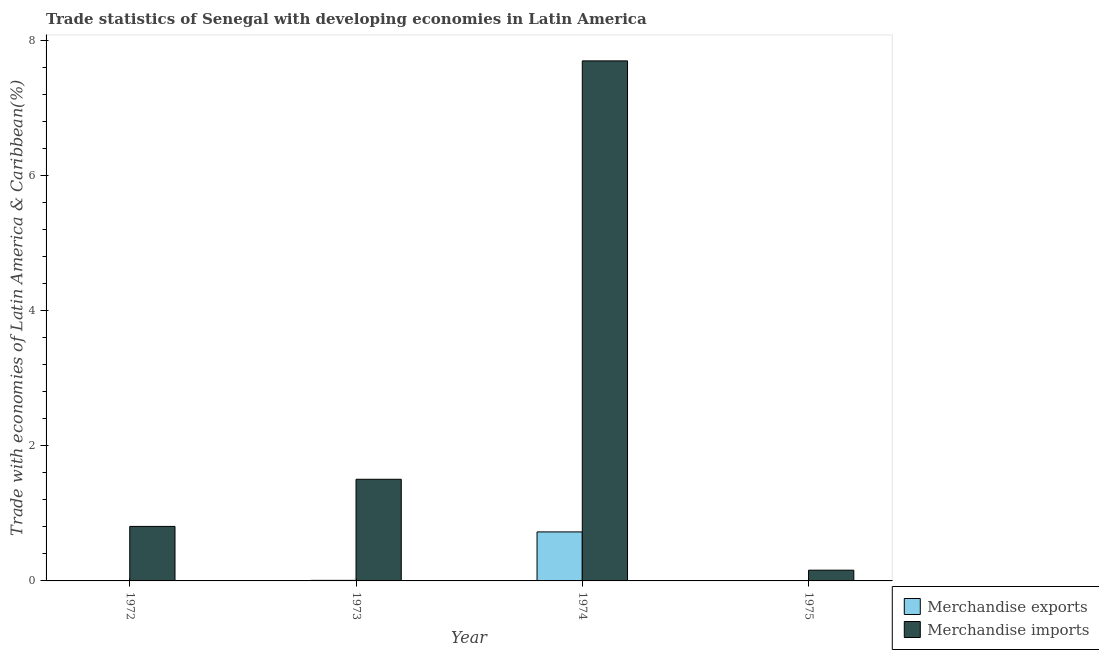How many different coloured bars are there?
Give a very brief answer. 2. How many groups of bars are there?
Give a very brief answer. 4. Are the number of bars on each tick of the X-axis equal?
Your answer should be compact. Yes. How many bars are there on the 1st tick from the left?
Keep it short and to the point. 2. How many bars are there on the 3rd tick from the right?
Your response must be concise. 2. What is the label of the 3rd group of bars from the left?
Your answer should be compact. 1974. In how many cases, is the number of bars for a given year not equal to the number of legend labels?
Your answer should be very brief. 0. What is the merchandise imports in 1972?
Ensure brevity in your answer.  0.81. Across all years, what is the maximum merchandise exports?
Keep it short and to the point. 0.73. Across all years, what is the minimum merchandise imports?
Offer a very short reply. 0.16. In which year was the merchandise imports maximum?
Your answer should be very brief. 1974. In which year was the merchandise imports minimum?
Offer a terse response. 1975. What is the total merchandise exports in the graph?
Offer a terse response. 0.74. What is the difference between the merchandise exports in 1974 and that in 1975?
Make the answer very short. 0.72. What is the difference between the merchandise imports in 1975 and the merchandise exports in 1972?
Ensure brevity in your answer.  -0.65. What is the average merchandise exports per year?
Your answer should be compact. 0.19. In the year 1974, what is the difference between the merchandise exports and merchandise imports?
Give a very brief answer. 0. What is the ratio of the merchandise imports in 1972 to that in 1975?
Ensure brevity in your answer.  5.08. Is the difference between the merchandise imports in 1973 and 1974 greater than the difference between the merchandise exports in 1973 and 1974?
Your answer should be very brief. No. What is the difference between the highest and the second highest merchandise imports?
Offer a terse response. 6.19. What is the difference between the highest and the lowest merchandise imports?
Your answer should be very brief. 7.54. In how many years, is the merchandise exports greater than the average merchandise exports taken over all years?
Keep it short and to the point. 1. Is the sum of the merchandise exports in 1974 and 1975 greater than the maximum merchandise imports across all years?
Ensure brevity in your answer.  Yes. What does the 2nd bar from the left in 1973 represents?
Make the answer very short. Merchandise imports. What does the 1st bar from the right in 1975 represents?
Keep it short and to the point. Merchandise imports. Are all the bars in the graph horizontal?
Provide a short and direct response. No. How many years are there in the graph?
Provide a short and direct response. 4. What is the difference between two consecutive major ticks on the Y-axis?
Offer a very short reply. 2. How are the legend labels stacked?
Your answer should be very brief. Vertical. What is the title of the graph?
Your response must be concise. Trade statistics of Senegal with developing economies in Latin America. Does "Females" appear as one of the legend labels in the graph?
Your response must be concise. No. What is the label or title of the Y-axis?
Give a very brief answer. Trade with economies of Latin America & Caribbean(%). What is the Trade with economies of Latin America & Caribbean(%) in Merchandise exports in 1972?
Your response must be concise. 0.01. What is the Trade with economies of Latin America & Caribbean(%) of Merchandise imports in 1972?
Your answer should be very brief. 0.81. What is the Trade with economies of Latin America & Caribbean(%) of Merchandise exports in 1973?
Offer a very short reply. 0.01. What is the Trade with economies of Latin America & Caribbean(%) of Merchandise imports in 1973?
Give a very brief answer. 1.5. What is the Trade with economies of Latin America & Caribbean(%) in Merchandise exports in 1974?
Your answer should be very brief. 0.73. What is the Trade with economies of Latin America & Caribbean(%) of Merchandise imports in 1974?
Provide a succinct answer. 7.7. What is the Trade with economies of Latin America & Caribbean(%) in Merchandise exports in 1975?
Your answer should be compact. 0. What is the Trade with economies of Latin America & Caribbean(%) of Merchandise imports in 1975?
Make the answer very short. 0.16. Across all years, what is the maximum Trade with economies of Latin America & Caribbean(%) in Merchandise exports?
Keep it short and to the point. 0.73. Across all years, what is the maximum Trade with economies of Latin America & Caribbean(%) in Merchandise imports?
Offer a very short reply. 7.7. Across all years, what is the minimum Trade with economies of Latin America & Caribbean(%) of Merchandise exports?
Your answer should be compact. 0. Across all years, what is the minimum Trade with economies of Latin America & Caribbean(%) of Merchandise imports?
Provide a short and direct response. 0.16. What is the total Trade with economies of Latin America & Caribbean(%) in Merchandise exports in the graph?
Your response must be concise. 0.74. What is the total Trade with economies of Latin America & Caribbean(%) in Merchandise imports in the graph?
Offer a terse response. 10.17. What is the difference between the Trade with economies of Latin America & Caribbean(%) in Merchandise exports in 1972 and that in 1973?
Ensure brevity in your answer.  -0. What is the difference between the Trade with economies of Latin America & Caribbean(%) of Merchandise imports in 1972 and that in 1973?
Offer a terse response. -0.7. What is the difference between the Trade with economies of Latin America & Caribbean(%) in Merchandise exports in 1972 and that in 1974?
Ensure brevity in your answer.  -0.72. What is the difference between the Trade with economies of Latin America & Caribbean(%) in Merchandise imports in 1972 and that in 1974?
Keep it short and to the point. -6.89. What is the difference between the Trade with economies of Latin America & Caribbean(%) in Merchandise exports in 1972 and that in 1975?
Offer a terse response. 0. What is the difference between the Trade with economies of Latin America & Caribbean(%) in Merchandise imports in 1972 and that in 1975?
Your answer should be very brief. 0.65. What is the difference between the Trade with economies of Latin America & Caribbean(%) in Merchandise exports in 1973 and that in 1974?
Provide a short and direct response. -0.72. What is the difference between the Trade with economies of Latin America & Caribbean(%) in Merchandise imports in 1973 and that in 1974?
Give a very brief answer. -6.19. What is the difference between the Trade with economies of Latin America & Caribbean(%) in Merchandise exports in 1973 and that in 1975?
Offer a very short reply. 0.01. What is the difference between the Trade with economies of Latin America & Caribbean(%) of Merchandise imports in 1973 and that in 1975?
Your response must be concise. 1.35. What is the difference between the Trade with economies of Latin America & Caribbean(%) in Merchandise exports in 1974 and that in 1975?
Give a very brief answer. 0.72. What is the difference between the Trade with economies of Latin America & Caribbean(%) of Merchandise imports in 1974 and that in 1975?
Provide a short and direct response. 7.54. What is the difference between the Trade with economies of Latin America & Caribbean(%) of Merchandise exports in 1972 and the Trade with economies of Latin America & Caribbean(%) of Merchandise imports in 1973?
Keep it short and to the point. -1.5. What is the difference between the Trade with economies of Latin America & Caribbean(%) in Merchandise exports in 1972 and the Trade with economies of Latin America & Caribbean(%) in Merchandise imports in 1974?
Provide a short and direct response. -7.69. What is the difference between the Trade with economies of Latin America & Caribbean(%) of Merchandise exports in 1972 and the Trade with economies of Latin America & Caribbean(%) of Merchandise imports in 1975?
Give a very brief answer. -0.15. What is the difference between the Trade with economies of Latin America & Caribbean(%) of Merchandise exports in 1973 and the Trade with economies of Latin America & Caribbean(%) of Merchandise imports in 1974?
Ensure brevity in your answer.  -7.69. What is the difference between the Trade with economies of Latin America & Caribbean(%) of Merchandise exports in 1973 and the Trade with economies of Latin America & Caribbean(%) of Merchandise imports in 1975?
Keep it short and to the point. -0.15. What is the difference between the Trade with economies of Latin America & Caribbean(%) of Merchandise exports in 1974 and the Trade with economies of Latin America & Caribbean(%) of Merchandise imports in 1975?
Your answer should be very brief. 0.57. What is the average Trade with economies of Latin America & Caribbean(%) of Merchandise exports per year?
Keep it short and to the point. 0.19. What is the average Trade with economies of Latin America & Caribbean(%) of Merchandise imports per year?
Keep it short and to the point. 2.54. In the year 1972, what is the difference between the Trade with economies of Latin America & Caribbean(%) of Merchandise exports and Trade with economies of Latin America & Caribbean(%) of Merchandise imports?
Keep it short and to the point. -0.8. In the year 1973, what is the difference between the Trade with economies of Latin America & Caribbean(%) in Merchandise exports and Trade with economies of Latin America & Caribbean(%) in Merchandise imports?
Provide a succinct answer. -1.5. In the year 1974, what is the difference between the Trade with economies of Latin America & Caribbean(%) in Merchandise exports and Trade with economies of Latin America & Caribbean(%) in Merchandise imports?
Offer a very short reply. -6.97. In the year 1975, what is the difference between the Trade with economies of Latin America & Caribbean(%) of Merchandise exports and Trade with economies of Latin America & Caribbean(%) of Merchandise imports?
Give a very brief answer. -0.16. What is the ratio of the Trade with economies of Latin America & Caribbean(%) of Merchandise exports in 1972 to that in 1973?
Provide a short and direct response. 0.73. What is the ratio of the Trade with economies of Latin America & Caribbean(%) in Merchandise imports in 1972 to that in 1973?
Provide a succinct answer. 0.54. What is the ratio of the Trade with economies of Latin America & Caribbean(%) in Merchandise exports in 1972 to that in 1974?
Your answer should be very brief. 0.01. What is the ratio of the Trade with economies of Latin America & Caribbean(%) in Merchandise imports in 1972 to that in 1974?
Your response must be concise. 0.1. What is the ratio of the Trade with economies of Latin America & Caribbean(%) of Merchandise exports in 1972 to that in 1975?
Ensure brevity in your answer.  1.98. What is the ratio of the Trade with economies of Latin America & Caribbean(%) of Merchandise imports in 1972 to that in 1975?
Ensure brevity in your answer.  5.08. What is the ratio of the Trade with economies of Latin America & Caribbean(%) of Merchandise exports in 1973 to that in 1974?
Ensure brevity in your answer.  0.01. What is the ratio of the Trade with economies of Latin America & Caribbean(%) of Merchandise imports in 1973 to that in 1974?
Provide a succinct answer. 0.2. What is the ratio of the Trade with economies of Latin America & Caribbean(%) of Merchandise exports in 1973 to that in 1975?
Your answer should be compact. 2.71. What is the ratio of the Trade with economies of Latin America & Caribbean(%) of Merchandise imports in 1973 to that in 1975?
Provide a short and direct response. 9.47. What is the ratio of the Trade with economies of Latin America & Caribbean(%) in Merchandise exports in 1974 to that in 1975?
Offer a very short reply. 239.55. What is the ratio of the Trade with economies of Latin America & Caribbean(%) of Merchandise imports in 1974 to that in 1975?
Your response must be concise. 48.43. What is the difference between the highest and the second highest Trade with economies of Latin America & Caribbean(%) in Merchandise exports?
Your answer should be very brief. 0.72. What is the difference between the highest and the second highest Trade with economies of Latin America & Caribbean(%) of Merchandise imports?
Ensure brevity in your answer.  6.19. What is the difference between the highest and the lowest Trade with economies of Latin America & Caribbean(%) in Merchandise exports?
Your response must be concise. 0.72. What is the difference between the highest and the lowest Trade with economies of Latin America & Caribbean(%) in Merchandise imports?
Make the answer very short. 7.54. 